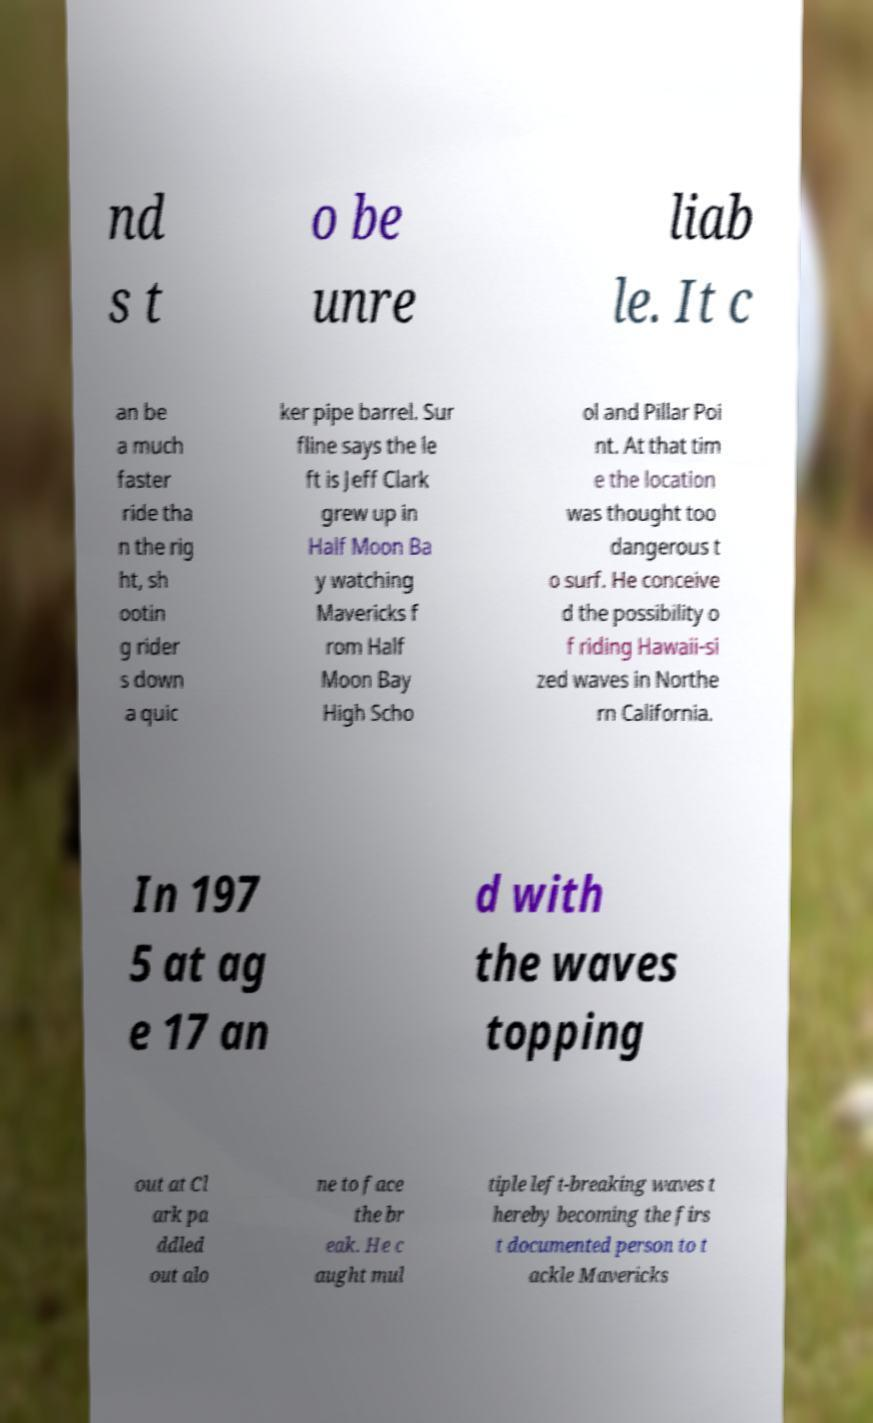Please read and relay the text visible in this image. What does it say? nd s t o be unre liab le. It c an be a much faster ride tha n the rig ht, sh ootin g rider s down a quic ker pipe barrel. Sur fline says the le ft is Jeff Clark grew up in Half Moon Ba y watching Mavericks f rom Half Moon Bay High Scho ol and Pillar Poi nt. At that tim e the location was thought too dangerous t o surf. He conceive d the possibility o f riding Hawaii-si zed waves in Northe rn California. In 197 5 at ag e 17 an d with the waves topping out at Cl ark pa ddled out alo ne to face the br eak. He c aught mul tiple left-breaking waves t hereby becoming the firs t documented person to t ackle Mavericks 